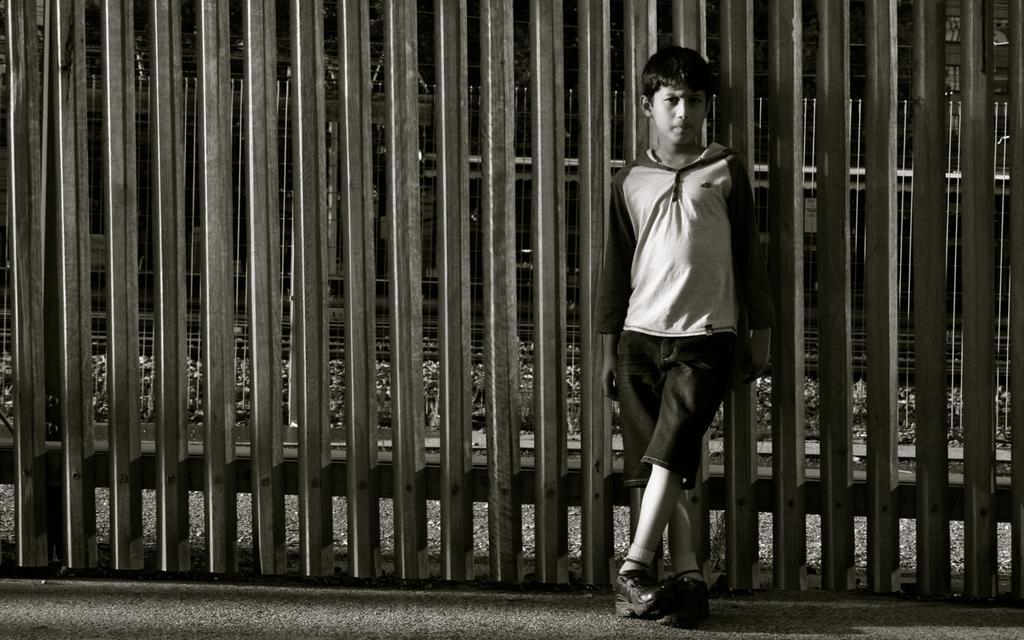How would you summarize this image in a sentence or two? In the image there is a boy with jacket and short is standing. Behind him there is a fencing. 